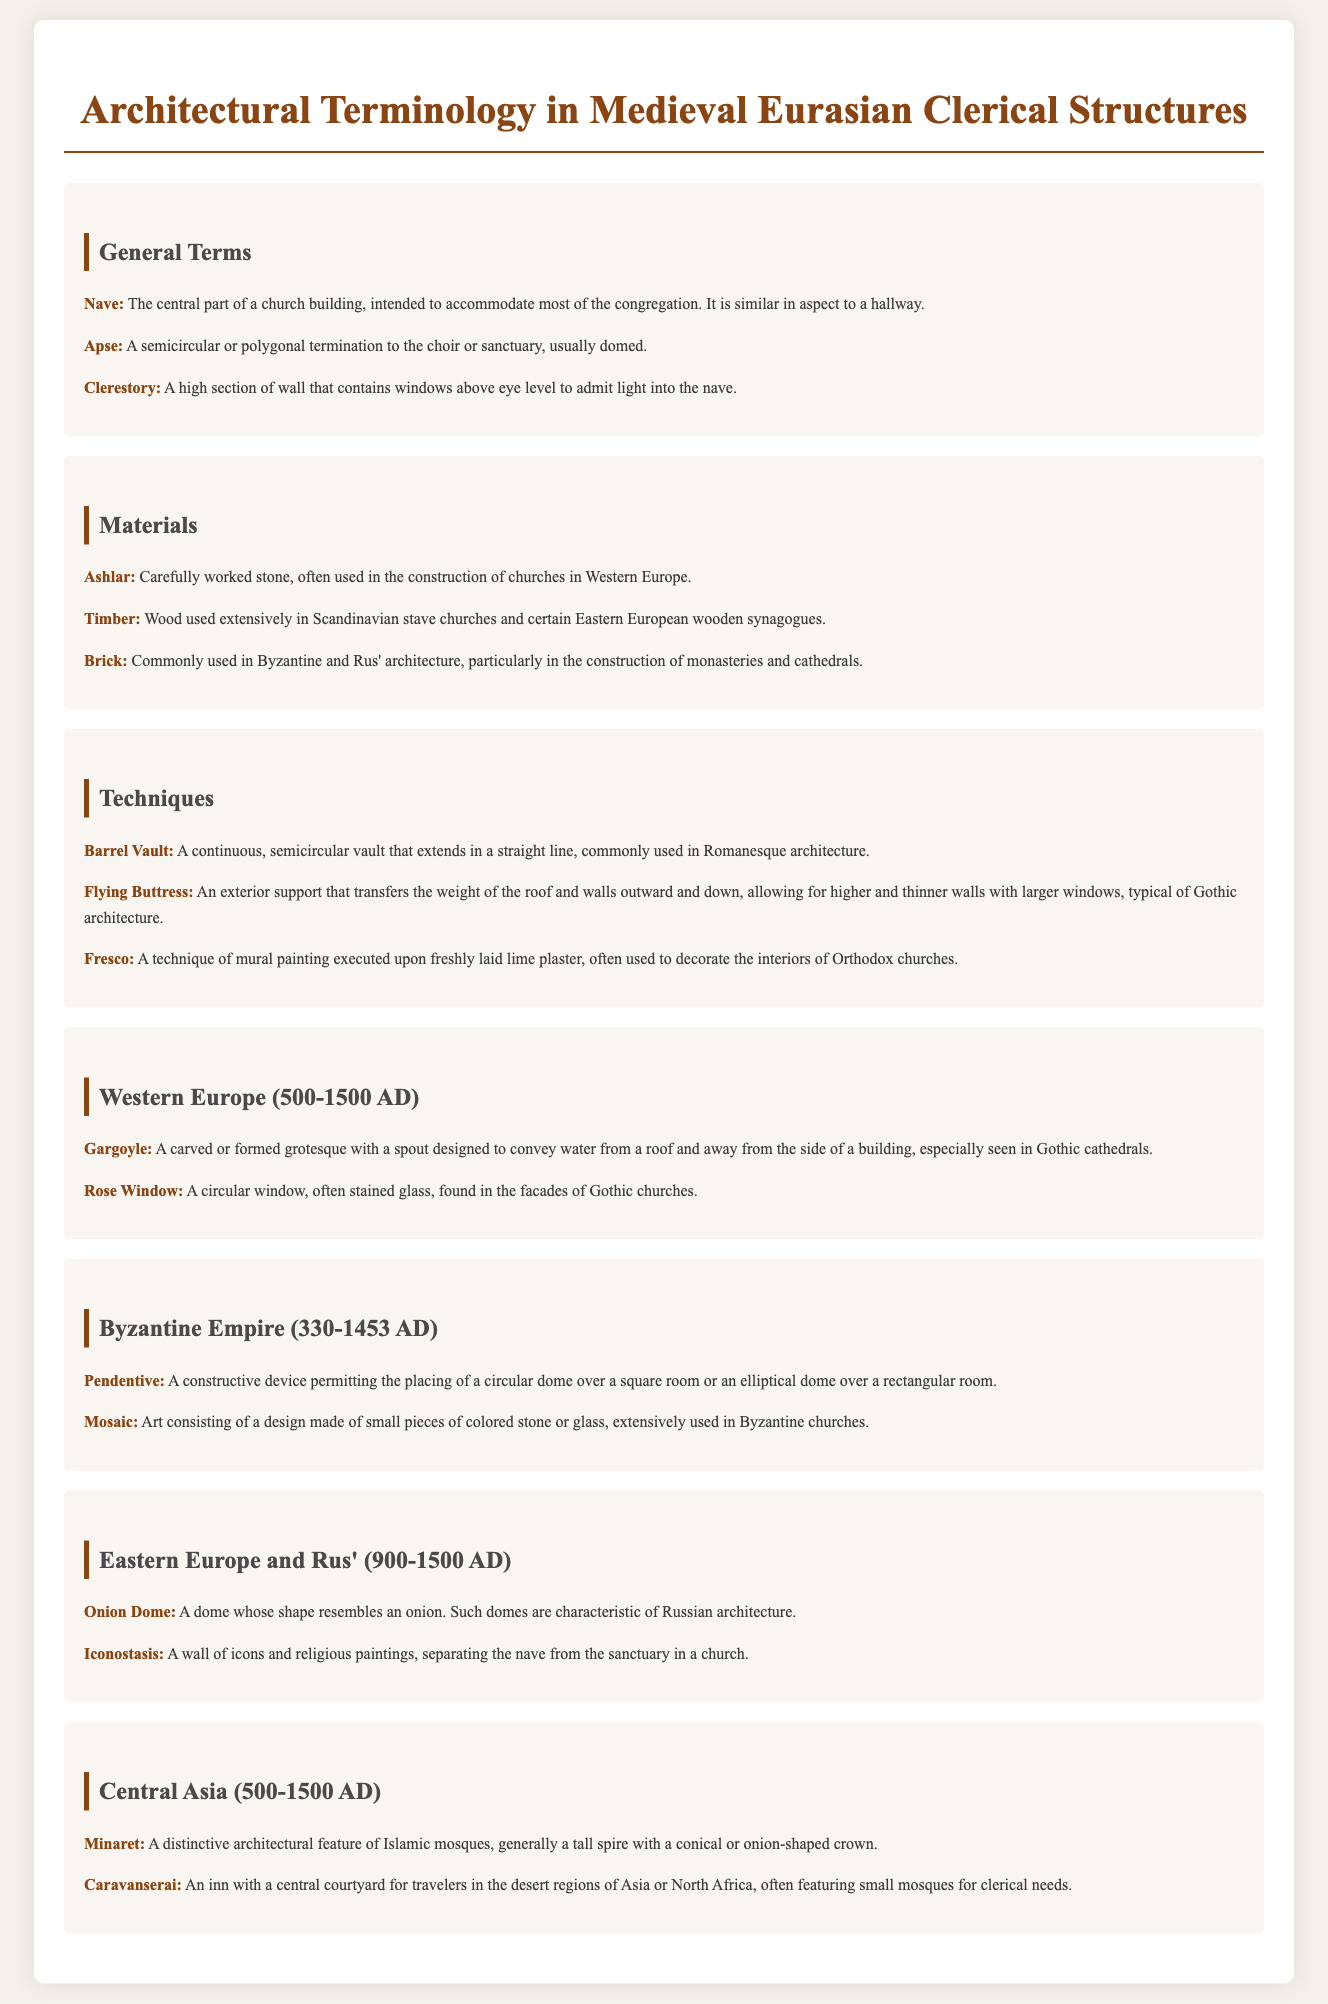What does the term "Nave" refer to? The definition describes the nave as the central part of a church building, intended to accommodate most of the congregation.
Answer: Central part of a church building What material is described as "Carefully worked stone"? The entry under materials specifies that ashlar is carefully worked stone, commonly used in Western European churches.
Answer: Ashlar What architectural feature is characteristic of Russian architecture? The glossary entry for Eastern Europe notes that onion domes are a characteristic shape in Russian architecture.
Answer: Onion Dome Which decorative painting technique is used in Orthodox churches? The document mentions that fresco is a technique used to decorate the interiors of Orthodox churches.
Answer: Fresco In which architectural style do flying buttresses appear? The definition states that flying buttresses are typical of Gothic architecture, transferring weight of structures.
Answer: Gothic architecture What is the primary purpose of a clerestory? The entry defines a clerestory as a high section of wall with windows to admit light into the nave.
Answer: Admit light into the nave How is a rose window characterized? The document states that a rose window is a circular window, often stained glass, found in Gothic churches.
Answer: Circular stained glass window What structure separates the nave from the sanctuary in a church? The entry for iconostasis explains that it serves to separate these two areas in a church.
Answer: Iconostasis 